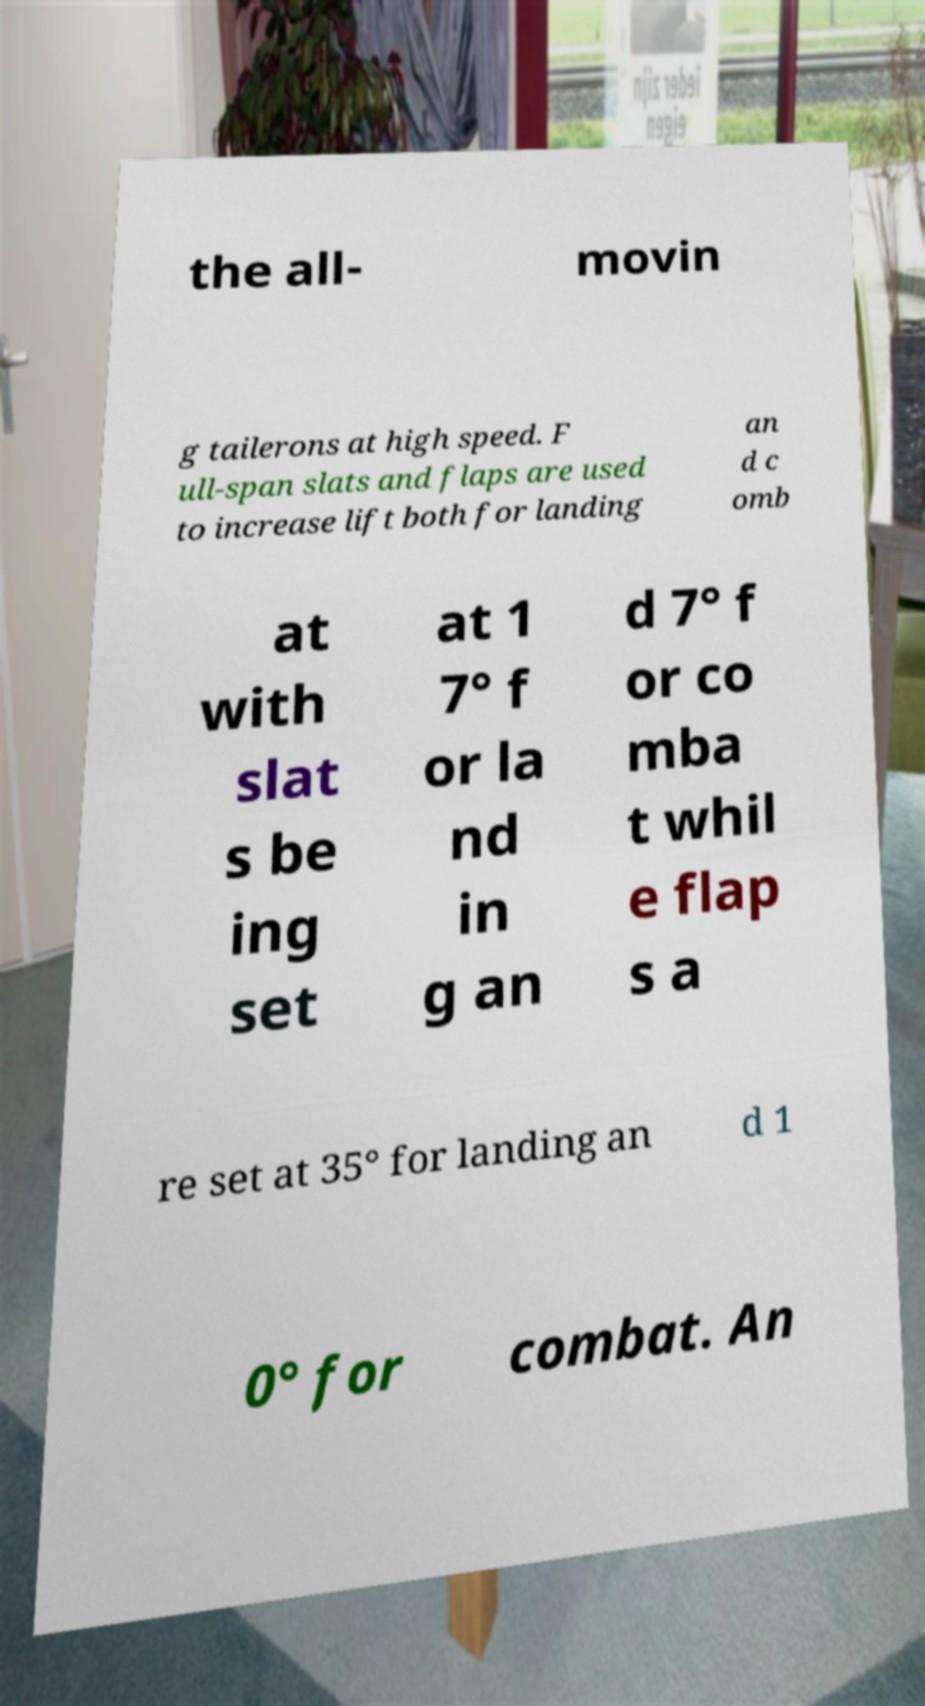There's text embedded in this image that I need extracted. Can you transcribe it verbatim? the all- movin g tailerons at high speed. F ull-span slats and flaps are used to increase lift both for landing an d c omb at with slat s be ing set at 1 7° f or la nd in g an d 7° f or co mba t whil e flap s a re set at 35° for landing an d 1 0° for combat. An 